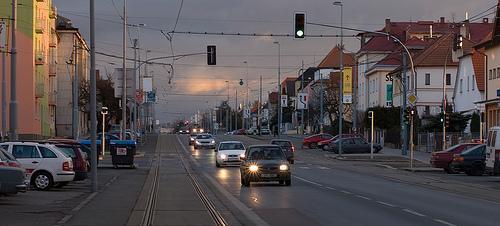How many cars are driving away?
Give a very brief answer. 1. How many traffic signals?
Give a very brief answer. 2. How many trash bins?
Give a very brief answer. 2. 